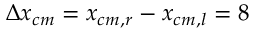<formula> <loc_0><loc_0><loc_500><loc_500>\Delta x _ { c m } = x _ { c m , r } - x _ { c m , l } = 8</formula> 